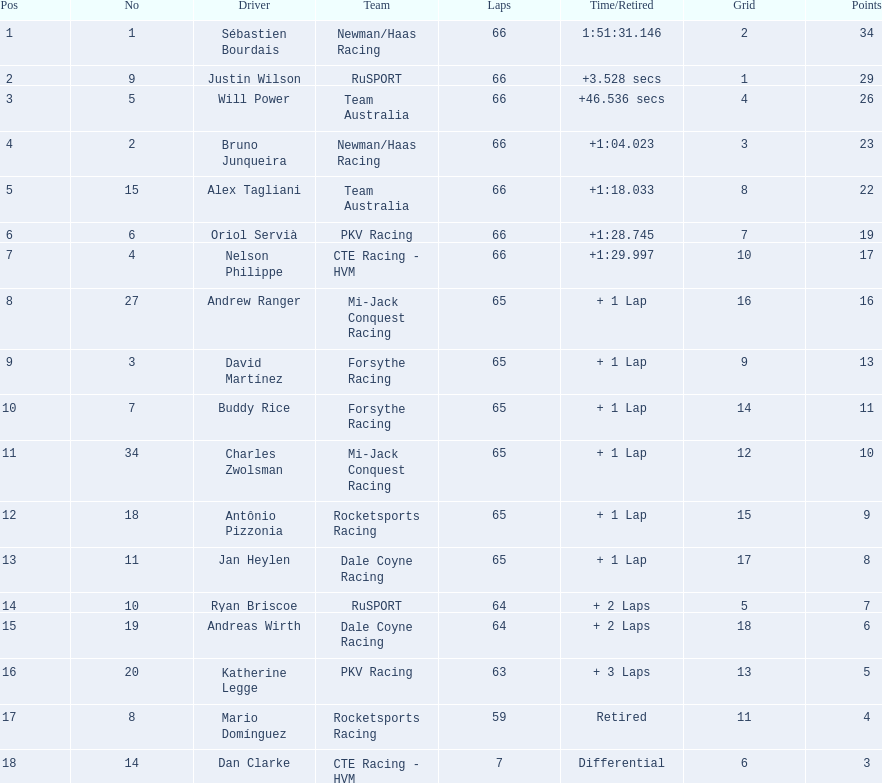Which drivers garnered no less than 10 points? Sébastien Bourdais, Justin Wilson, Will Power, Bruno Junqueira, Alex Tagliani, Oriol Servià, Nelson Philippe, Andrew Ranger, David Martínez, Buddy Rice, Charles Zwolsman. Of these drivers, who secured a minimum of 20 points? Sébastien Bourdais, Justin Wilson, Will Power, Bruno Junqueira, Alex Tagliani. From the five highest-scoring ones, who had the maximum points? Sébastien Bourdais. 